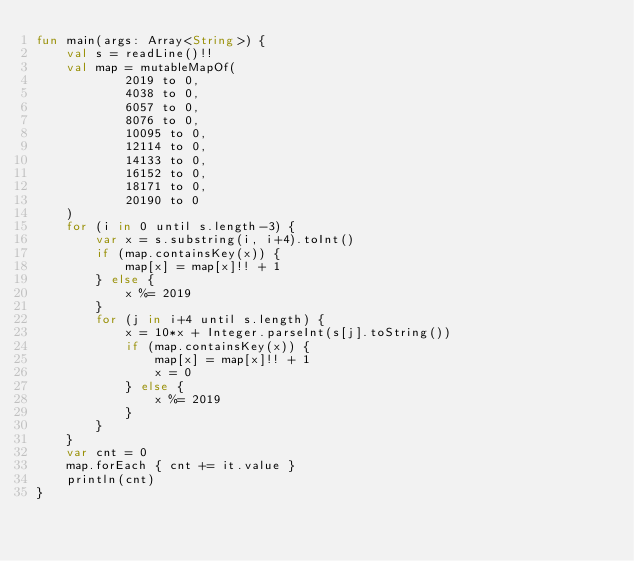<code> <loc_0><loc_0><loc_500><loc_500><_Kotlin_>fun main(args: Array<String>) {
    val s = readLine()!!
    val map = mutableMapOf(
            2019 to 0,
            4038 to 0,
            6057 to 0,
            8076 to 0,
            10095 to 0,
            12114 to 0,
            14133 to 0,
            16152 to 0,
            18171 to 0,
            20190 to 0
    )
    for (i in 0 until s.length-3) {
        var x = s.substring(i, i+4).toInt()
        if (map.containsKey(x)) {
            map[x] = map[x]!! + 1
        } else {
            x %= 2019
        }
        for (j in i+4 until s.length) {
            x = 10*x + Integer.parseInt(s[j].toString())
            if (map.containsKey(x)) {
                map[x] = map[x]!! + 1
                x = 0
            } else {
                x %= 2019
            }
        }
    }
    var cnt = 0
    map.forEach { cnt += it.value }
    println(cnt)
}
</code> 